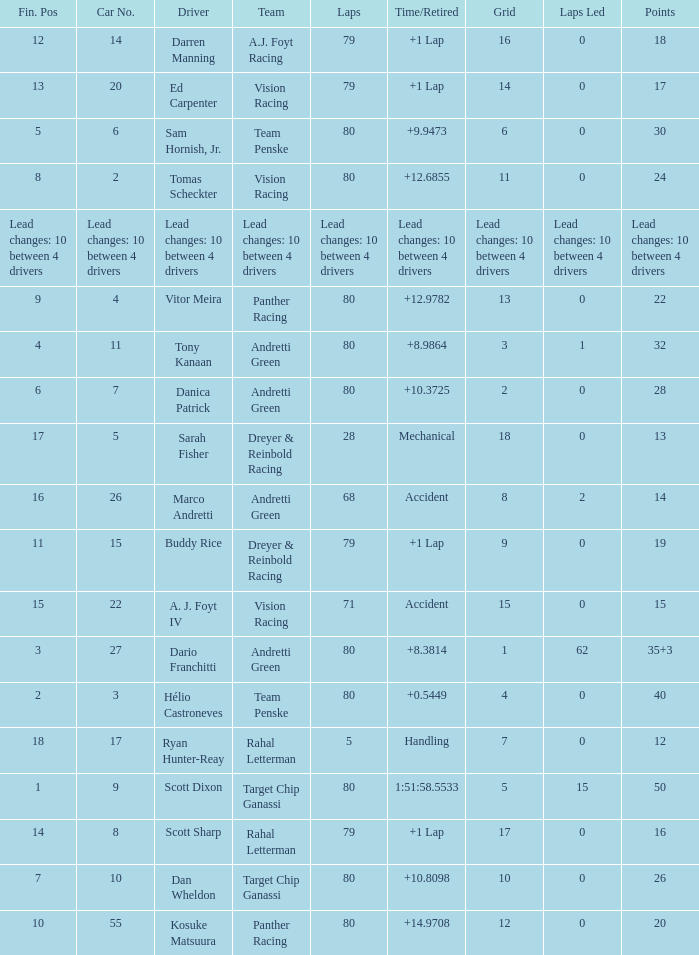Which group possesses 26 points? Target Chip Ganassi. 